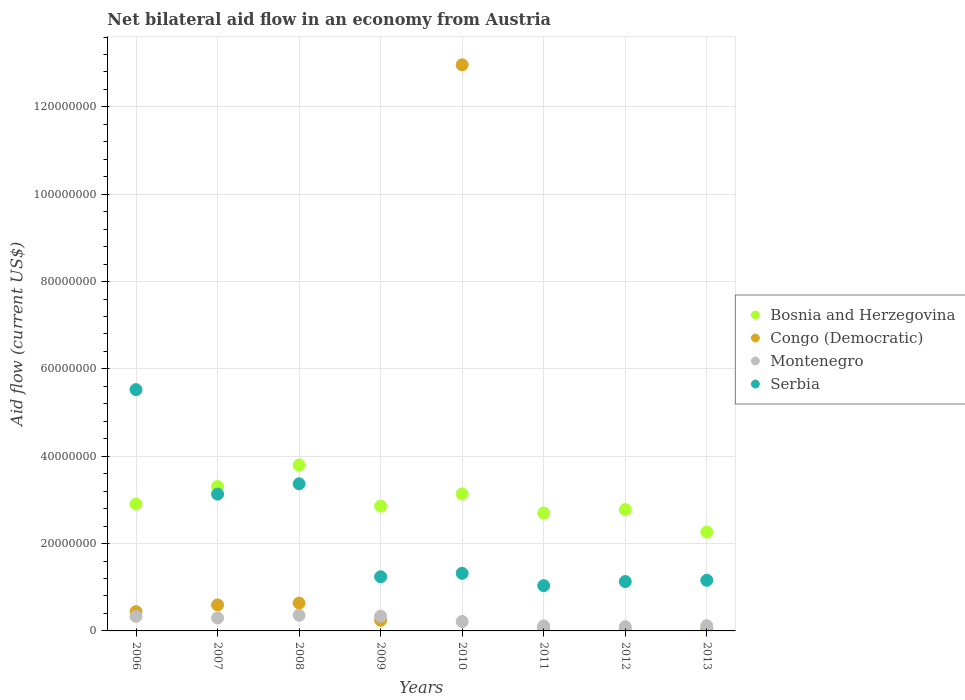How many different coloured dotlines are there?
Your response must be concise. 4. What is the net bilateral aid flow in Bosnia and Herzegovina in 2009?
Your response must be concise. 2.86e+07. Across all years, what is the maximum net bilateral aid flow in Serbia?
Make the answer very short. 5.53e+07. Across all years, what is the minimum net bilateral aid flow in Serbia?
Make the answer very short. 1.04e+07. In which year was the net bilateral aid flow in Montenegro maximum?
Your response must be concise. 2008. What is the total net bilateral aid flow in Congo (Democratic) in the graph?
Keep it short and to the point. 1.50e+08. What is the difference between the net bilateral aid flow in Serbia in 2006 and the net bilateral aid flow in Montenegro in 2009?
Give a very brief answer. 5.19e+07. What is the average net bilateral aid flow in Bosnia and Herzegovina per year?
Your answer should be very brief. 2.97e+07. In the year 2010, what is the difference between the net bilateral aid flow in Congo (Democratic) and net bilateral aid flow in Bosnia and Herzegovina?
Ensure brevity in your answer.  9.83e+07. What is the ratio of the net bilateral aid flow in Montenegro in 2008 to that in 2013?
Offer a very short reply. 3.01. Is the net bilateral aid flow in Serbia in 2006 less than that in 2008?
Offer a terse response. No. What is the difference between the highest and the second highest net bilateral aid flow in Serbia?
Offer a very short reply. 2.16e+07. What is the difference between the highest and the lowest net bilateral aid flow in Bosnia and Herzegovina?
Offer a terse response. 1.54e+07. In how many years, is the net bilateral aid flow in Bosnia and Herzegovina greater than the average net bilateral aid flow in Bosnia and Herzegovina taken over all years?
Your answer should be compact. 3. Is it the case that in every year, the sum of the net bilateral aid flow in Bosnia and Herzegovina and net bilateral aid flow in Serbia  is greater than the sum of net bilateral aid flow in Congo (Democratic) and net bilateral aid flow in Montenegro?
Give a very brief answer. No. Does the net bilateral aid flow in Congo (Democratic) monotonically increase over the years?
Your answer should be very brief. No. How many dotlines are there?
Your answer should be very brief. 4. How many years are there in the graph?
Provide a short and direct response. 8. What is the difference between two consecutive major ticks on the Y-axis?
Your answer should be compact. 2.00e+07. Does the graph contain any zero values?
Your response must be concise. No. How are the legend labels stacked?
Give a very brief answer. Vertical. What is the title of the graph?
Offer a terse response. Net bilateral aid flow in an economy from Austria. Does "Switzerland" appear as one of the legend labels in the graph?
Offer a terse response. No. What is the label or title of the Y-axis?
Your answer should be compact. Aid flow (current US$). What is the Aid flow (current US$) of Bosnia and Herzegovina in 2006?
Provide a succinct answer. 2.91e+07. What is the Aid flow (current US$) of Congo (Democratic) in 2006?
Give a very brief answer. 4.41e+06. What is the Aid flow (current US$) in Montenegro in 2006?
Make the answer very short. 3.34e+06. What is the Aid flow (current US$) of Serbia in 2006?
Your response must be concise. 5.53e+07. What is the Aid flow (current US$) of Bosnia and Herzegovina in 2007?
Your answer should be compact. 3.31e+07. What is the Aid flow (current US$) of Congo (Democratic) in 2007?
Your answer should be very brief. 5.95e+06. What is the Aid flow (current US$) in Montenegro in 2007?
Your response must be concise. 2.97e+06. What is the Aid flow (current US$) of Serbia in 2007?
Give a very brief answer. 3.13e+07. What is the Aid flow (current US$) of Bosnia and Herzegovina in 2008?
Ensure brevity in your answer.  3.80e+07. What is the Aid flow (current US$) in Congo (Democratic) in 2008?
Ensure brevity in your answer.  6.38e+06. What is the Aid flow (current US$) of Montenegro in 2008?
Provide a short and direct response. 3.58e+06. What is the Aid flow (current US$) in Serbia in 2008?
Ensure brevity in your answer.  3.37e+07. What is the Aid flow (current US$) of Bosnia and Herzegovina in 2009?
Offer a terse response. 2.86e+07. What is the Aid flow (current US$) of Congo (Democratic) in 2009?
Make the answer very short. 2.43e+06. What is the Aid flow (current US$) in Montenegro in 2009?
Your response must be concise. 3.37e+06. What is the Aid flow (current US$) in Serbia in 2009?
Your answer should be compact. 1.24e+07. What is the Aid flow (current US$) of Bosnia and Herzegovina in 2010?
Keep it short and to the point. 3.14e+07. What is the Aid flow (current US$) in Congo (Democratic) in 2010?
Provide a short and direct response. 1.30e+08. What is the Aid flow (current US$) in Montenegro in 2010?
Offer a terse response. 2.15e+06. What is the Aid flow (current US$) of Serbia in 2010?
Keep it short and to the point. 1.32e+07. What is the Aid flow (current US$) of Bosnia and Herzegovina in 2011?
Give a very brief answer. 2.70e+07. What is the Aid flow (current US$) of Congo (Democratic) in 2011?
Offer a very short reply. 7.10e+05. What is the Aid flow (current US$) in Montenegro in 2011?
Make the answer very short. 1.16e+06. What is the Aid flow (current US$) in Serbia in 2011?
Ensure brevity in your answer.  1.04e+07. What is the Aid flow (current US$) of Bosnia and Herzegovina in 2012?
Offer a very short reply. 2.78e+07. What is the Aid flow (current US$) of Montenegro in 2012?
Provide a succinct answer. 9.60e+05. What is the Aid flow (current US$) of Serbia in 2012?
Give a very brief answer. 1.13e+07. What is the Aid flow (current US$) in Bosnia and Herzegovina in 2013?
Give a very brief answer. 2.26e+07. What is the Aid flow (current US$) in Montenegro in 2013?
Offer a very short reply. 1.19e+06. What is the Aid flow (current US$) in Serbia in 2013?
Offer a very short reply. 1.16e+07. Across all years, what is the maximum Aid flow (current US$) in Bosnia and Herzegovina?
Your answer should be very brief. 3.80e+07. Across all years, what is the maximum Aid flow (current US$) in Congo (Democratic)?
Your answer should be very brief. 1.30e+08. Across all years, what is the maximum Aid flow (current US$) of Montenegro?
Offer a very short reply. 3.58e+06. Across all years, what is the maximum Aid flow (current US$) of Serbia?
Keep it short and to the point. 5.53e+07. Across all years, what is the minimum Aid flow (current US$) in Bosnia and Herzegovina?
Your answer should be compact. 2.26e+07. Across all years, what is the minimum Aid flow (current US$) of Congo (Democratic)?
Offer a very short reply. 2.40e+05. Across all years, what is the minimum Aid flow (current US$) in Montenegro?
Provide a succinct answer. 9.60e+05. Across all years, what is the minimum Aid flow (current US$) in Serbia?
Provide a succinct answer. 1.04e+07. What is the total Aid flow (current US$) of Bosnia and Herzegovina in the graph?
Make the answer very short. 2.38e+08. What is the total Aid flow (current US$) of Congo (Democratic) in the graph?
Your answer should be compact. 1.50e+08. What is the total Aid flow (current US$) in Montenegro in the graph?
Your answer should be very brief. 1.87e+07. What is the total Aid flow (current US$) of Serbia in the graph?
Provide a short and direct response. 1.79e+08. What is the difference between the Aid flow (current US$) of Bosnia and Herzegovina in 2006 and that in 2007?
Offer a very short reply. -4.01e+06. What is the difference between the Aid flow (current US$) of Congo (Democratic) in 2006 and that in 2007?
Ensure brevity in your answer.  -1.54e+06. What is the difference between the Aid flow (current US$) of Serbia in 2006 and that in 2007?
Offer a terse response. 2.39e+07. What is the difference between the Aid flow (current US$) in Bosnia and Herzegovina in 2006 and that in 2008?
Offer a very short reply. -8.93e+06. What is the difference between the Aid flow (current US$) in Congo (Democratic) in 2006 and that in 2008?
Provide a succinct answer. -1.97e+06. What is the difference between the Aid flow (current US$) of Serbia in 2006 and that in 2008?
Offer a terse response. 2.16e+07. What is the difference between the Aid flow (current US$) of Bosnia and Herzegovina in 2006 and that in 2009?
Your answer should be very brief. 4.80e+05. What is the difference between the Aid flow (current US$) of Congo (Democratic) in 2006 and that in 2009?
Provide a succinct answer. 1.98e+06. What is the difference between the Aid flow (current US$) in Montenegro in 2006 and that in 2009?
Ensure brevity in your answer.  -3.00e+04. What is the difference between the Aid flow (current US$) in Serbia in 2006 and that in 2009?
Offer a very short reply. 4.29e+07. What is the difference between the Aid flow (current US$) in Bosnia and Herzegovina in 2006 and that in 2010?
Keep it short and to the point. -2.31e+06. What is the difference between the Aid flow (current US$) of Congo (Democratic) in 2006 and that in 2010?
Make the answer very short. -1.25e+08. What is the difference between the Aid flow (current US$) of Montenegro in 2006 and that in 2010?
Ensure brevity in your answer.  1.19e+06. What is the difference between the Aid flow (current US$) of Serbia in 2006 and that in 2010?
Offer a very short reply. 4.21e+07. What is the difference between the Aid flow (current US$) in Bosnia and Herzegovina in 2006 and that in 2011?
Provide a short and direct response. 2.06e+06. What is the difference between the Aid flow (current US$) of Congo (Democratic) in 2006 and that in 2011?
Offer a terse response. 3.70e+06. What is the difference between the Aid flow (current US$) of Montenegro in 2006 and that in 2011?
Make the answer very short. 2.18e+06. What is the difference between the Aid flow (current US$) in Serbia in 2006 and that in 2011?
Give a very brief answer. 4.49e+07. What is the difference between the Aid flow (current US$) of Bosnia and Herzegovina in 2006 and that in 2012?
Offer a terse response. 1.29e+06. What is the difference between the Aid flow (current US$) in Congo (Democratic) in 2006 and that in 2012?
Offer a terse response. 4.17e+06. What is the difference between the Aid flow (current US$) in Montenegro in 2006 and that in 2012?
Your answer should be compact. 2.38e+06. What is the difference between the Aid flow (current US$) of Serbia in 2006 and that in 2012?
Offer a terse response. 4.40e+07. What is the difference between the Aid flow (current US$) in Bosnia and Herzegovina in 2006 and that in 2013?
Your answer should be very brief. 6.42e+06. What is the difference between the Aid flow (current US$) in Congo (Democratic) in 2006 and that in 2013?
Your answer should be very brief. 4.02e+06. What is the difference between the Aid flow (current US$) in Montenegro in 2006 and that in 2013?
Your answer should be compact. 2.15e+06. What is the difference between the Aid flow (current US$) in Serbia in 2006 and that in 2013?
Offer a very short reply. 4.37e+07. What is the difference between the Aid flow (current US$) of Bosnia and Herzegovina in 2007 and that in 2008?
Offer a very short reply. -4.92e+06. What is the difference between the Aid flow (current US$) in Congo (Democratic) in 2007 and that in 2008?
Your response must be concise. -4.30e+05. What is the difference between the Aid flow (current US$) of Montenegro in 2007 and that in 2008?
Your answer should be very brief. -6.10e+05. What is the difference between the Aid flow (current US$) in Serbia in 2007 and that in 2008?
Your answer should be very brief. -2.36e+06. What is the difference between the Aid flow (current US$) in Bosnia and Herzegovina in 2007 and that in 2009?
Your response must be concise. 4.49e+06. What is the difference between the Aid flow (current US$) of Congo (Democratic) in 2007 and that in 2009?
Provide a succinct answer. 3.52e+06. What is the difference between the Aid flow (current US$) of Montenegro in 2007 and that in 2009?
Keep it short and to the point. -4.00e+05. What is the difference between the Aid flow (current US$) in Serbia in 2007 and that in 2009?
Your answer should be compact. 1.89e+07. What is the difference between the Aid flow (current US$) in Bosnia and Herzegovina in 2007 and that in 2010?
Your answer should be very brief. 1.70e+06. What is the difference between the Aid flow (current US$) of Congo (Democratic) in 2007 and that in 2010?
Make the answer very short. -1.24e+08. What is the difference between the Aid flow (current US$) in Montenegro in 2007 and that in 2010?
Provide a short and direct response. 8.20e+05. What is the difference between the Aid flow (current US$) of Serbia in 2007 and that in 2010?
Offer a very short reply. 1.81e+07. What is the difference between the Aid flow (current US$) of Bosnia and Herzegovina in 2007 and that in 2011?
Ensure brevity in your answer.  6.07e+06. What is the difference between the Aid flow (current US$) of Congo (Democratic) in 2007 and that in 2011?
Your answer should be very brief. 5.24e+06. What is the difference between the Aid flow (current US$) of Montenegro in 2007 and that in 2011?
Provide a succinct answer. 1.81e+06. What is the difference between the Aid flow (current US$) of Serbia in 2007 and that in 2011?
Your response must be concise. 2.10e+07. What is the difference between the Aid flow (current US$) of Bosnia and Herzegovina in 2007 and that in 2012?
Offer a terse response. 5.30e+06. What is the difference between the Aid flow (current US$) in Congo (Democratic) in 2007 and that in 2012?
Give a very brief answer. 5.71e+06. What is the difference between the Aid flow (current US$) of Montenegro in 2007 and that in 2012?
Offer a terse response. 2.01e+06. What is the difference between the Aid flow (current US$) of Serbia in 2007 and that in 2012?
Your answer should be compact. 2.00e+07. What is the difference between the Aid flow (current US$) of Bosnia and Herzegovina in 2007 and that in 2013?
Give a very brief answer. 1.04e+07. What is the difference between the Aid flow (current US$) in Congo (Democratic) in 2007 and that in 2013?
Keep it short and to the point. 5.56e+06. What is the difference between the Aid flow (current US$) in Montenegro in 2007 and that in 2013?
Provide a short and direct response. 1.78e+06. What is the difference between the Aid flow (current US$) in Serbia in 2007 and that in 2013?
Your answer should be very brief. 1.97e+07. What is the difference between the Aid flow (current US$) in Bosnia and Herzegovina in 2008 and that in 2009?
Ensure brevity in your answer.  9.41e+06. What is the difference between the Aid flow (current US$) of Congo (Democratic) in 2008 and that in 2009?
Make the answer very short. 3.95e+06. What is the difference between the Aid flow (current US$) of Montenegro in 2008 and that in 2009?
Provide a short and direct response. 2.10e+05. What is the difference between the Aid flow (current US$) of Serbia in 2008 and that in 2009?
Provide a succinct answer. 2.13e+07. What is the difference between the Aid flow (current US$) in Bosnia and Herzegovina in 2008 and that in 2010?
Keep it short and to the point. 6.62e+06. What is the difference between the Aid flow (current US$) of Congo (Democratic) in 2008 and that in 2010?
Your response must be concise. -1.23e+08. What is the difference between the Aid flow (current US$) of Montenegro in 2008 and that in 2010?
Your answer should be compact. 1.43e+06. What is the difference between the Aid flow (current US$) of Serbia in 2008 and that in 2010?
Ensure brevity in your answer.  2.05e+07. What is the difference between the Aid flow (current US$) in Bosnia and Herzegovina in 2008 and that in 2011?
Your answer should be compact. 1.10e+07. What is the difference between the Aid flow (current US$) in Congo (Democratic) in 2008 and that in 2011?
Keep it short and to the point. 5.67e+06. What is the difference between the Aid flow (current US$) in Montenegro in 2008 and that in 2011?
Offer a very short reply. 2.42e+06. What is the difference between the Aid flow (current US$) in Serbia in 2008 and that in 2011?
Offer a terse response. 2.33e+07. What is the difference between the Aid flow (current US$) in Bosnia and Herzegovina in 2008 and that in 2012?
Provide a short and direct response. 1.02e+07. What is the difference between the Aid flow (current US$) of Congo (Democratic) in 2008 and that in 2012?
Keep it short and to the point. 6.14e+06. What is the difference between the Aid flow (current US$) in Montenegro in 2008 and that in 2012?
Give a very brief answer. 2.62e+06. What is the difference between the Aid flow (current US$) of Serbia in 2008 and that in 2012?
Your answer should be very brief. 2.24e+07. What is the difference between the Aid flow (current US$) of Bosnia and Herzegovina in 2008 and that in 2013?
Provide a succinct answer. 1.54e+07. What is the difference between the Aid flow (current US$) of Congo (Democratic) in 2008 and that in 2013?
Provide a succinct answer. 5.99e+06. What is the difference between the Aid flow (current US$) in Montenegro in 2008 and that in 2013?
Your answer should be very brief. 2.39e+06. What is the difference between the Aid flow (current US$) in Serbia in 2008 and that in 2013?
Provide a succinct answer. 2.21e+07. What is the difference between the Aid flow (current US$) in Bosnia and Herzegovina in 2009 and that in 2010?
Offer a terse response. -2.79e+06. What is the difference between the Aid flow (current US$) in Congo (Democratic) in 2009 and that in 2010?
Provide a succinct answer. -1.27e+08. What is the difference between the Aid flow (current US$) of Montenegro in 2009 and that in 2010?
Give a very brief answer. 1.22e+06. What is the difference between the Aid flow (current US$) of Serbia in 2009 and that in 2010?
Your answer should be very brief. -7.90e+05. What is the difference between the Aid flow (current US$) in Bosnia and Herzegovina in 2009 and that in 2011?
Provide a short and direct response. 1.58e+06. What is the difference between the Aid flow (current US$) of Congo (Democratic) in 2009 and that in 2011?
Keep it short and to the point. 1.72e+06. What is the difference between the Aid flow (current US$) in Montenegro in 2009 and that in 2011?
Your response must be concise. 2.21e+06. What is the difference between the Aid flow (current US$) in Serbia in 2009 and that in 2011?
Offer a very short reply. 2.03e+06. What is the difference between the Aid flow (current US$) in Bosnia and Herzegovina in 2009 and that in 2012?
Give a very brief answer. 8.10e+05. What is the difference between the Aid flow (current US$) of Congo (Democratic) in 2009 and that in 2012?
Provide a short and direct response. 2.19e+06. What is the difference between the Aid flow (current US$) in Montenegro in 2009 and that in 2012?
Your response must be concise. 2.41e+06. What is the difference between the Aid flow (current US$) of Serbia in 2009 and that in 2012?
Provide a succinct answer. 1.09e+06. What is the difference between the Aid flow (current US$) in Bosnia and Herzegovina in 2009 and that in 2013?
Provide a succinct answer. 5.94e+06. What is the difference between the Aid flow (current US$) of Congo (Democratic) in 2009 and that in 2013?
Your answer should be compact. 2.04e+06. What is the difference between the Aid flow (current US$) of Montenegro in 2009 and that in 2013?
Your answer should be compact. 2.18e+06. What is the difference between the Aid flow (current US$) in Serbia in 2009 and that in 2013?
Make the answer very short. 8.10e+05. What is the difference between the Aid flow (current US$) in Bosnia and Herzegovina in 2010 and that in 2011?
Make the answer very short. 4.37e+06. What is the difference between the Aid flow (current US$) in Congo (Democratic) in 2010 and that in 2011?
Your response must be concise. 1.29e+08. What is the difference between the Aid flow (current US$) in Montenegro in 2010 and that in 2011?
Provide a succinct answer. 9.90e+05. What is the difference between the Aid flow (current US$) in Serbia in 2010 and that in 2011?
Your answer should be very brief. 2.82e+06. What is the difference between the Aid flow (current US$) of Bosnia and Herzegovina in 2010 and that in 2012?
Ensure brevity in your answer.  3.60e+06. What is the difference between the Aid flow (current US$) in Congo (Democratic) in 2010 and that in 2012?
Provide a short and direct response. 1.29e+08. What is the difference between the Aid flow (current US$) in Montenegro in 2010 and that in 2012?
Offer a terse response. 1.19e+06. What is the difference between the Aid flow (current US$) in Serbia in 2010 and that in 2012?
Your answer should be compact. 1.88e+06. What is the difference between the Aid flow (current US$) in Bosnia and Herzegovina in 2010 and that in 2013?
Your answer should be very brief. 8.73e+06. What is the difference between the Aid flow (current US$) of Congo (Democratic) in 2010 and that in 2013?
Offer a very short reply. 1.29e+08. What is the difference between the Aid flow (current US$) of Montenegro in 2010 and that in 2013?
Your response must be concise. 9.60e+05. What is the difference between the Aid flow (current US$) in Serbia in 2010 and that in 2013?
Your answer should be very brief. 1.60e+06. What is the difference between the Aid flow (current US$) of Bosnia and Herzegovina in 2011 and that in 2012?
Provide a short and direct response. -7.70e+05. What is the difference between the Aid flow (current US$) in Congo (Democratic) in 2011 and that in 2012?
Offer a very short reply. 4.70e+05. What is the difference between the Aid flow (current US$) of Serbia in 2011 and that in 2012?
Provide a short and direct response. -9.40e+05. What is the difference between the Aid flow (current US$) in Bosnia and Herzegovina in 2011 and that in 2013?
Keep it short and to the point. 4.36e+06. What is the difference between the Aid flow (current US$) in Montenegro in 2011 and that in 2013?
Offer a terse response. -3.00e+04. What is the difference between the Aid flow (current US$) in Serbia in 2011 and that in 2013?
Offer a terse response. -1.22e+06. What is the difference between the Aid flow (current US$) in Bosnia and Herzegovina in 2012 and that in 2013?
Offer a very short reply. 5.13e+06. What is the difference between the Aid flow (current US$) of Congo (Democratic) in 2012 and that in 2013?
Your response must be concise. -1.50e+05. What is the difference between the Aid flow (current US$) in Serbia in 2012 and that in 2013?
Ensure brevity in your answer.  -2.80e+05. What is the difference between the Aid flow (current US$) of Bosnia and Herzegovina in 2006 and the Aid flow (current US$) of Congo (Democratic) in 2007?
Your answer should be compact. 2.31e+07. What is the difference between the Aid flow (current US$) in Bosnia and Herzegovina in 2006 and the Aid flow (current US$) in Montenegro in 2007?
Offer a very short reply. 2.61e+07. What is the difference between the Aid flow (current US$) in Bosnia and Herzegovina in 2006 and the Aid flow (current US$) in Serbia in 2007?
Give a very brief answer. -2.26e+06. What is the difference between the Aid flow (current US$) in Congo (Democratic) in 2006 and the Aid flow (current US$) in Montenegro in 2007?
Make the answer very short. 1.44e+06. What is the difference between the Aid flow (current US$) of Congo (Democratic) in 2006 and the Aid flow (current US$) of Serbia in 2007?
Give a very brief answer. -2.69e+07. What is the difference between the Aid flow (current US$) of Montenegro in 2006 and the Aid flow (current US$) of Serbia in 2007?
Keep it short and to the point. -2.80e+07. What is the difference between the Aid flow (current US$) in Bosnia and Herzegovina in 2006 and the Aid flow (current US$) in Congo (Democratic) in 2008?
Provide a short and direct response. 2.27e+07. What is the difference between the Aid flow (current US$) of Bosnia and Herzegovina in 2006 and the Aid flow (current US$) of Montenegro in 2008?
Ensure brevity in your answer.  2.55e+07. What is the difference between the Aid flow (current US$) of Bosnia and Herzegovina in 2006 and the Aid flow (current US$) of Serbia in 2008?
Keep it short and to the point. -4.62e+06. What is the difference between the Aid flow (current US$) in Congo (Democratic) in 2006 and the Aid flow (current US$) in Montenegro in 2008?
Give a very brief answer. 8.30e+05. What is the difference between the Aid flow (current US$) in Congo (Democratic) in 2006 and the Aid flow (current US$) in Serbia in 2008?
Ensure brevity in your answer.  -2.93e+07. What is the difference between the Aid flow (current US$) of Montenegro in 2006 and the Aid flow (current US$) of Serbia in 2008?
Your response must be concise. -3.04e+07. What is the difference between the Aid flow (current US$) in Bosnia and Herzegovina in 2006 and the Aid flow (current US$) in Congo (Democratic) in 2009?
Provide a succinct answer. 2.66e+07. What is the difference between the Aid flow (current US$) in Bosnia and Herzegovina in 2006 and the Aid flow (current US$) in Montenegro in 2009?
Your answer should be compact. 2.57e+07. What is the difference between the Aid flow (current US$) of Bosnia and Herzegovina in 2006 and the Aid flow (current US$) of Serbia in 2009?
Your response must be concise. 1.67e+07. What is the difference between the Aid flow (current US$) of Congo (Democratic) in 2006 and the Aid flow (current US$) of Montenegro in 2009?
Offer a very short reply. 1.04e+06. What is the difference between the Aid flow (current US$) of Congo (Democratic) in 2006 and the Aid flow (current US$) of Serbia in 2009?
Keep it short and to the point. -7.99e+06. What is the difference between the Aid flow (current US$) in Montenegro in 2006 and the Aid flow (current US$) in Serbia in 2009?
Provide a succinct answer. -9.06e+06. What is the difference between the Aid flow (current US$) of Bosnia and Herzegovina in 2006 and the Aid flow (current US$) of Congo (Democratic) in 2010?
Offer a very short reply. -1.01e+08. What is the difference between the Aid flow (current US$) of Bosnia and Herzegovina in 2006 and the Aid flow (current US$) of Montenegro in 2010?
Your answer should be very brief. 2.69e+07. What is the difference between the Aid flow (current US$) of Bosnia and Herzegovina in 2006 and the Aid flow (current US$) of Serbia in 2010?
Provide a succinct answer. 1.59e+07. What is the difference between the Aid flow (current US$) in Congo (Democratic) in 2006 and the Aid flow (current US$) in Montenegro in 2010?
Your answer should be compact. 2.26e+06. What is the difference between the Aid flow (current US$) of Congo (Democratic) in 2006 and the Aid flow (current US$) of Serbia in 2010?
Make the answer very short. -8.78e+06. What is the difference between the Aid flow (current US$) in Montenegro in 2006 and the Aid flow (current US$) in Serbia in 2010?
Your response must be concise. -9.85e+06. What is the difference between the Aid flow (current US$) in Bosnia and Herzegovina in 2006 and the Aid flow (current US$) in Congo (Democratic) in 2011?
Make the answer very short. 2.84e+07. What is the difference between the Aid flow (current US$) of Bosnia and Herzegovina in 2006 and the Aid flow (current US$) of Montenegro in 2011?
Offer a very short reply. 2.79e+07. What is the difference between the Aid flow (current US$) of Bosnia and Herzegovina in 2006 and the Aid flow (current US$) of Serbia in 2011?
Keep it short and to the point. 1.87e+07. What is the difference between the Aid flow (current US$) of Congo (Democratic) in 2006 and the Aid flow (current US$) of Montenegro in 2011?
Your response must be concise. 3.25e+06. What is the difference between the Aid flow (current US$) of Congo (Democratic) in 2006 and the Aid flow (current US$) of Serbia in 2011?
Offer a very short reply. -5.96e+06. What is the difference between the Aid flow (current US$) in Montenegro in 2006 and the Aid flow (current US$) in Serbia in 2011?
Keep it short and to the point. -7.03e+06. What is the difference between the Aid flow (current US$) of Bosnia and Herzegovina in 2006 and the Aid flow (current US$) of Congo (Democratic) in 2012?
Provide a short and direct response. 2.88e+07. What is the difference between the Aid flow (current US$) of Bosnia and Herzegovina in 2006 and the Aid flow (current US$) of Montenegro in 2012?
Offer a very short reply. 2.81e+07. What is the difference between the Aid flow (current US$) of Bosnia and Herzegovina in 2006 and the Aid flow (current US$) of Serbia in 2012?
Your answer should be very brief. 1.78e+07. What is the difference between the Aid flow (current US$) in Congo (Democratic) in 2006 and the Aid flow (current US$) in Montenegro in 2012?
Make the answer very short. 3.45e+06. What is the difference between the Aid flow (current US$) in Congo (Democratic) in 2006 and the Aid flow (current US$) in Serbia in 2012?
Give a very brief answer. -6.90e+06. What is the difference between the Aid flow (current US$) of Montenegro in 2006 and the Aid flow (current US$) of Serbia in 2012?
Provide a succinct answer. -7.97e+06. What is the difference between the Aid flow (current US$) of Bosnia and Herzegovina in 2006 and the Aid flow (current US$) of Congo (Democratic) in 2013?
Keep it short and to the point. 2.87e+07. What is the difference between the Aid flow (current US$) of Bosnia and Herzegovina in 2006 and the Aid flow (current US$) of Montenegro in 2013?
Provide a short and direct response. 2.79e+07. What is the difference between the Aid flow (current US$) of Bosnia and Herzegovina in 2006 and the Aid flow (current US$) of Serbia in 2013?
Provide a short and direct response. 1.75e+07. What is the difference between the Aid flow (current US$) of Congo (Democratic) in 2006 and the Aid flow (current US$) of Montenegro in 2013?
Your response must be concise. 3.22e+06. What is the difference between the Aid flow (current US$) in Congo (Democratic) in 2006 and the Aid flow (current US$) in Serbia in 2013?
Offer a terse response. -7.18e+06. What is the difference between the Aid flow (current US$) of Montenegro in 2006 and the Aid flow (current US$) of Serbia in 2013?
Provide a short and direct response. -8.25e+06. What is the difference between the Aid flow (current US$) in Bosnia and Herzegovina in 2007 and the Aid flow (current US$) in Congo (Democratic) in 2008?
Ensure brevity in your answer.  2.67e+07. What is the difference between the Aid flow (current US$) in Bosnia and Herzegovina in 2007 and the Aid flow (current US$) in Montenegro in 2008?
Offer a very short reply. 2.95e+07. What is the difference between the Aid flow (current US$) in Bosnia and Herzegovina in 2007 and the Aid flow (current US$) in Serbia in 2008?
Offer a terse response. -6.10e+05. What is the difference between the Aid flow (current US$) in Congo (Democratic) in 2007 and the Aid flow (current US$) in Montenegro in 2008?
Provide a succinct answer. 2.37e+06. What is the difference between the Aid flow (current US$) of Congo (Democratic) in 2007 and the Aid flow (current US$) of Serbia in 2008?
Your answer should be compact. -2.77e+07. What is the difference between the Aid flow (current US$) in Montenegro in 2007 and the Aid flow (current US$) in Serbia in 2008?
Make the answer very short. -3.07e+07. What is the difference between the Aid flow (current US$) of Bosnia and Herzegovina in 2007 and the Aid flow (current US$) of Congo (Democratic) in 2009?
Ensure brevity in your answer.  3.06e+07. What is the difference between the Aid flow (current US$) of Bosnia and Herzegovina in 2007 and the Aid flow (current US$) of Montenegro in 2009?
Your answer should be compact. 2.97e+07. What is the difference between the Aid flow (current US$) in Bosnia and Herzegovina in 2007 and the Aid flow (current US$) in Serbia in 2009?
Your response must be concise. 2.07e+07. What is the difference between the Aid flow (current US$) of Congo (Democratic) in 2007 and the Aid flow (current US$) of Montenegro in 2009?
Keep it short and to the point. 2.58e+06. What is the difference between the Aid flow (current US$) in Congo (Democratic) in 2007 and the Aid flow (current US$) in Serbia in 2009?
Offer a terse response. -6.45e+06. What is the difference between the Aid flow (current US$) in Montenegro in 2007 and the Aid flow (current US$) in Serbia in 2009?
Offer a terse response. -9.43e+06. What is the difference between the Aid flow (current US$) in Bosnia and Herzegovina in 2007 and the Aid flow (current US$) in Congo (Democratic) in 2010?
Your response must be concise. -9.66e+07. What is the difference between the Aid flow (current US$) in Bosnia and Herzegovina in 2007 and the Aid flow (current US$) in Montenegro in 2010?
Provide a short and direct response. 3.09e+07. What is the difference between the Aid flow (current US$) in Bosnia and Herzegovina in 2007 and the Aid flow (current US$) in Serbia in 2010?
Offer a terse response. 1.99e+07. What is the difference between the Aid flow (current US$) in Congo (Democratic) in 2007 and the Aid flow (current US$) in Montenegro in 2010?
Offer a very short reply. 3.80e+06. What is the difference between the Aid flow (current US$) in Congo (Democratic) in 2007 and the Aid flow (current US$) in Serbia in 2010?
Ensure brevity in your answer.  -7.24e+06. What is the difference between the Aid flow (current US$) in Montenegro in 2007 and the Aid flow (current US$) in Serbia in 2010?
Your answer should be very brief. -1.02e+07. What is the difference between the Aid flow (current US$) in Bosnia and Herzegovina in 2007 and the Aid flow (current US$) in Congo (Democratic) in 2011?
Provide a succinct answer. 3.24e+07. What is the difference between the Aid flow (current US$) in Bosnia and Herzegovina in 2007 and the Aid flow (current US$) in Montenegro in 2011?
Ensure brevity in your answer.  3.19e+07. What is the difference between the Aid flow (current US$) of Bosnia and Herzegovina in 2007 and the Aid flow (current US$) of Serbia in 2011?
Ensure brevity in your answer.  2.27e+07. What is the difference between the Aid flow (current US$) of Congo (Democratic) in 2007 and the Aid flow (current US$) of Montenegro in 2011?
Give a very brief answer. 4.79e+06. What is the difference between the Aid flow (current US$) in Congo (Democratic) in 2007 and the Aid flow (current US$) in Serbia in 2011?
Offer a terse response. -4.42e+06. What is the difference between the Aid flow (current US$) in Montenegro in 2007 and the Aid flow (current US$) in Serbia in 2011?
Provide a short and direct response. -7.40e+06. What is the difference between the Aid flow (current US$) of Bosnia and Herzegovina in 2007 and the Aid flow (current US$) of Congo (Democratic) in 2012?
Give a very brief answer. 3.28e+07. What is the difference between the Aid flow (current US$) of Bosnia and Herzegovina in 2007 and the Aid flow (current US$) of Montenegro in 2012?
Offer a very short reply. 3.21e+07. What is the difference between the Aid flow (current US$) in Bosnia and Herzegovina in 2007 and the Aid flow (current US$) in Serbia in 2012?
Ensure brevity in your answer.  2.18e+07. What is the difference between the Aid flow (current US$) in Congo (Democratic) in 2007 and the Aid flow (current US$) in Montenegro in 2012?
Provide a succinct answer. 4.99e+06. What is the difference between the Aid flow (current US$) in Congo (Democratic) in 2007 and the Aid flow (current US$) in Serbia in 2012?
Your answer should be very brief. -5.36e+06. What is the difference between the Aid flow (current US$) of Montenegro in 2007 and the Aid flow (current US$) of Serbia in 2012?
Keep it short and to the point. -8.34e+06. What is the difference between the Aid flow (current US$) of Bosnia and Herzegovina in 2007 and the Aid flow (current US$) of Congo (Democratic) in 2013?
Offer a terse response. 3.27e+07. What is the difference between the Aid flow (current US$) in Bosnia and Herzegovina in 2007 and the Aid flow (current US$) in Montenegro in 2013?
Provide a short and direct response. 3.19e+07. What is the difference between the Aid flow (current US$) in Bosnia and Herzegovina in 2007 and the Aid flow (current US$) in Serbia in 2013?
Provide a short and direct response. 2.15e+07. What is the difference between the Aid flow (current US$) of Congo (Democratic) in 2007 and the Aid flow (current US$) of Montenegro in 2013?
Your response must be concise. 4.76e+06. What is the difference between the Aid flow (current US$) of Congo (Democratic) in 2007 and the Aid flow (current US$) of Serbia in 2013?
Offer a very short reply. -5.64e+06. What is the difference between the Aid flow (current US$) of Montenegro in 2007 and the Aid flow (current US$) of Serbia in 2013?
Make the answer very short. -8.62e+06. What is the difference between the Aid flow (current US$) of Bosnia and Herzegovina in 2008 and the Aid flow (current US$) of Congo (Democratic) in 2009?
Offer a terse response. 3.56e+07. What is the difference between the Aid flow (current US$) of Bosnia and Herzegovina in 2008 and the Aid flow (current US$) of Montenegro in 2009?
Offer a terse response. 3.46e+07. What is the difference between the Aid flow (current US$) in Bosnia and Herzegovina in 2008 and the Aid flow (current US$) in Serbia in 2009?
Your response must be concise. 2.56e+07. What is the difference between the Aid flow (current US$) of Congo (Democratic) in 2008 and the Aid flow (current US$) of Montenegro in 2009?
Offer a very short reply. 3.01e+06. What is the difference between the Aid flow (current US$) of Congo (Democratic) in 2008 and the Aid flow (current US$) of Serbia in 2009?
Offer a terse response. -6.02e+06. What is the difference between the Aid flow (current US$) of Montenegro in 2008 and the Aid flow (current US$) of Serbia in 2009?
Provide a short and direct response. -8.82e+06. What is the difference between the Aid flow (current US$) of Bosnia and Herzegovina in 2008 and the Aid flow (current US$) of Congo (Democratic) in 2010?
Make the answer very short. -9.16e+07. What is the difference between the Aid flow (current US$) of Bosnia and Herzegovina in 2008 and the Aid flow (current US$) of Montenegro in 2010?
Offer a terse response. 3.58e+07. What is the difference between the Aid flow (current US$) of Bosnia and Herzegovina in 2008 and the Aid flow (current US$) of Serbia in 2010?
Provide a succinct answer. 2.48e+07. What is the difference between the Aid flow (current US$) in Congo (Democratic) in 2008 and the Aid flow (current US$) in Montenegro in 2010?
Your answer should be compact. 4.23e+06. What is the difference between the Aid flow (current US$) of Congo (Democratic) in 2008 and the Aid flow (current US$) of Serbia in 2010?
Make the answer very short. -6.81e+06. What is the difference between the Aid flow (current US$) of Montenegro in 2008 and the Aid flow (current US$) of Serbia in 2010?
Provide a succinct answer. -9.61e+06. What is the difference between the Aid flow (current US$) of Bosnia and Herzegovina in 2008 and the Aid flow (current US$) of Congo (Democratic) in 2011?
Keep it short and to the point. 3.73e+07. What is the difference between the Aid flow (current US$) in Bosnia and Herzegovina in 2008 and the Aid flow (current US$) in Montenegro in 2011?
Your response must be concise. 3.68e+07. What is the difference between the Aid flow (current US$) of Bosnia and Herzegovina in 2008 and the Aid flow (current US$) of Serbia in 2011?
Make the answer very short. 2.76e+07. What is the difference between the Aid flow (current US$) in Congo (Democratic) in 2008 and the Aid flow (current US$) in Montenegro in 2011?
Offer a very short reply. 5.22e+06. What is the difference between the Aid flow (current US$) of Congo (Democratic) in 2008 and the Aid flow (current US$) of Serbia in 2011?
Provide a short and direct response. -3.99e+06. What is the difference between the Aid flow (current US$) in Montenegro in 2008 and the Aid flow (current US$) in Serbia in 2011?
Ensure brevity in your answer.  -6.79e+06. What is the difference between the Aid flow (current US$) in Bosnia and Herzegovina in 2008 and the Aid flow (current US$) in Congo (Democratic) in 2012?
Give a very brief answer. 3.78e+07. What is the difference between the Aid flow (current US$) in Bosnia and Herzegovina in 2008 and the Aid flow (current US$) in Montenegro in 2012?
Offer a very short reply. 3.70e+07. What is the difference between the Aid flow (current US$) of Bosnia and Herzegovina in 2008 and the Aid flow (current US$) of Serbia in 2012?
Provide a succinct answer. 2.67e+07. What is the difference between the Aid flow (current US$) of Congo (Democratic) in 2008 and the Aid flow (current US$) of Montenegro in 2012?
Your answer should be very brief. 5.42e+06. What is the difference between the Aid flow (current US$) of Congo (Democratic) in 2008 and the Aid flow (current US$) of Serbia in 2012?
Give a very brief answer. -4.93e+06. What is the difference between the Aid flow (current US$) of Montenegro in 2008 and the Aid flow (current US$) of Serbia in 2012?
Make the answer very short. -7.73e+06. What is the difference between the Aid flow (current US$) in Bosnia and Herzegovina in 2008 and the Aid flow (current US$) in Congo (Democratic) in 2013?
Make the answer very short. 3.76e+07. What is the difference between the Aid flow (current US$) in Bosnia and Herzegovina in 2008 and the Aid flow (current US$) in Montenegro in 2013?
Give a very brief answer. 3.68e+07. What is the difference between the Aid flow (current US$) in Bosnia and Herzegovina in 2008 and the Aid flow (current US$) in Serbia in 2013?
Offer a very short reply. 2.64e+07. What is the difference between the Aid flow (current US$) in Congo (Democratic) in 2008 and the Aid flow (current US$) in Montenegro in 2013?
Keep it short and to the point. 5.19e+06. What is the difference between the Aid flow (current US$) of Congo (Democratic) in 2008 and the Aid flow (current US$) of Serbia in 2013?
Keep it short and to the point. -5.21e+06. What is the difference between the Aid flow (current US$) in Montenegro in 2008 and the Aid flow (current US$) in Serbia in 2013?
Your response must be concise. -8.01e+06. What is the difference between the Aid flow (current US$) in Bosnia and Herzegovina in 2009 and the Aid flow (current US$) in Congo (Democratic) in 2010?
Make the answer very short. -1.01e+08. What is the difference between the Aid flow (current US$) of Bosnia and Herzegovina in 2009 and the Aid flow (current US$) of Montenegro in 2010?
Provide a short and direct response. 2.64e+07. What is the difference between the Aid flow (current US$) of Bosnia and Herzegovina in 2009 and the Aid flow (current US$) of Serbia in 2010?
Give a very brief answer. 1.54e+07. What is the difference between the Aid flow (current US$) in Congo (Democratic) in 2009 and the Aid flow (current US$) in Montenegro in 2010?
Provide a short and direct response. 2.80e+05. What is the difference between the Aid flow (current US$) of Congo (Democratic) in 2009 and the Aid flow (current US$) of Serbia in 2010?
Make the answer very short. -1.08e+07. What is the difference between the Aid flow (current US$) in Montenegro in 2009 and the Aid flow (current US$) in Serbia in 2010?
Keep it short and to the point. -9.82e+06. What is the difference between the Aid flow (current US$) of Bosnia and Herzegovina in 2009 and the Aid flow (current US$) of Congo (Democratic) in 2011?
Your answer should be compact. 2.79e+07. What is the difference between the Aid flow (current US$) in Bosnia and Herzegovina in 2009 and the Aid flow (current US$) in Montenegro in 2011?
Give a very brief answer. 2.74e+07. What is the difference between the Aid flow (current US$) of Bosnia and Herzegovina in 2009 and the Aid flow (current US$) of Serbia in 2011?
Offer a very short reply. 1.82e+07. What is the difference between the Aid flow (current US$) in Congo (Democratic) in 2009 and the Aid flow (current US$) in Montenegro in 2011?
Give a very brief answer. 1.27e+06. What is the difference between the Aid flow (current US$) of Congo (Democratic) in 2009 and the Aid flow (current US$) of Serbia in 2011?
Provide a succinct answer. -7.94e+06. What is the difference between the Aid flow (current US$) of Montenegro in 2009 and the Aid flow (current US$) of Serbia in 2011?
Provide a short and direct response. -7.00e+06. What is the difference between the Aid flow (current US$) of Bosnia and Herzegovina in 2009 and the Aid flow (current US$) of Congo (Democratic) in 2012?
Offer a terse response. 2.84e+07. What is the difference between the Aid flow (current US$) of Bosnia and Herzegovina in 2009 and the Aid flow (current US$) of Montenegro in 2012?
Keep it short and to the point. 2.76e+07. What is the difference between the Aid flow (current US$) of Bosnia and Herzegovina in 2009 and the Aid flow (current US$) of Serbia in 2012?
Ensure brevity in your answer.  1.73e+07. What is the difference between the Aid flow (current US$) in Congo (Democratic) in 2009 and the Aid flow (current US$) in Montenegro in 2012?
Keep it short and to the point. 1.47e+06. What is the difference between the Aid flow (current US$) of Congo (Democratic) in 2009 and the Aid flow (current US$) of Serbia in 2012?
Your answer should be compact. -8.88e+06. What is the difference between the Aid flow (current US$) in Montenegro in 2009 and the Aid flow (current US$) in Serbia in 2012?
Keep it short and to the point. -7.94e+06. What is the difference between the Aid flow (current US$) in Bosnia and Herzegovina in 2009 and the Aid flow (current US$) in Congo (Democratic) in 2013?
Give a very brief answer. 2.82e+07. What is the difference between the Aid flow (current US$) in Bosnia and Herzegovina in 2009 and the Aid flow (current US$) in Montenegro in 2013?
Offer a very short reply. 2.74e+07. What is the difference between the Aid flow (current US$) in Bosnia and Herzegovina in 2009 and the Aid flow (current US$) in Serbia in 2013?
Provide a succinct answer. 1.70e+07. What is the difference between the Aid flow (current US$) of Congo (Democratic) in 2009 and the Aid flow (current US$) of Montenegro in 2013?
Ensure brevity in your answer.  1.24e+06. What is the difference between the Aid flow (current US$) in Congo (Democratic) in 2009 and the Aid flow (current US$) in Serbia in 2013?
Your answer should be compact. -9.16e+06. What is the difference between the Aid flow (current US$) in Montenegro in 2009 and the Aid flow (current US$) in Serbia in 2013?
Your response must be concise. -8.22e+06. What is the difference between the Aid flow (current US$) in Bosnia and Herzegovina in 2010 and the Aid flow (current US$) in Congo (Democratic) in 2011?
Offer a terse response. 3.07e+07. What is the difference between the Aid flow (current US$) in Bosnia and Herzegovina in 2010 and the Aid flow (current US$) in Montenegro in 2011?
Keep it short and to the point. 3.02e+07. What is the difference between the Aid flow (current US$) in Bosnia and Herzegovina in 2010 and the Aid flow (current US$) in Serbia in 2011?
Offer a terse response. 2.10e+07. What is the difference between the Aid flow (current US$) in Congo (Democratic) in 2010 and the Aid flow (current US$) in Montenegro in 2011?
Offer a terse response. 1.28e+08. What is the difference between the Aid flow (current US$) of Congo (Democratic) in 2010 and the Aid flow (current US$) of Serbia in 2011?
Your answer should be compact. 1.19e+08. What is the difference between the Aid flow (current US$) in Montenegro in 2010 and the Aid flow (current US$) in Serbia in 2011?
Provide a short and direct response. -8.22e+06. What is the difference between the Aid flow (current US$) in Bosnia and Herzegovina in 2010 and the Aid flow (current US$) in Congo (Democratic) in 2012?
Offer a terse response. 3.11e+07. What is the difference between the Aid flow (current US$) in Bosnia and Herzegovina in 2010 and the Aid flow (current US$) in Montenegro in 2012?
Offer a terse response. 3.04e+07. What is the difference between the Aid flow (current US$) in Bosnia and Herzegovina in 2010 and the Aid flow (current US$) in Serbia in 2012?
Your answer should be compact. 2.01e+07. What is the difference between the Aid flow (current US$) in Congo (Democratic) in 2010 and the Aid flow (current US$) in Montenegro in 2012?
Provide a short and direct response. 1.29e+08. What is the difference between the Aid flow (current US$) in Congo (Democratic) in 2010 and the Aid flow (current US$) in Serbia in 2012?
Provide a short and direct response. 1.18e+08. What is the difference between the Aid flow (current US$) in Montenegro in 2010 and the Aid flow (current US$) in Serbia in 2012?
Ensure brevity in your answer.  -9.16e+06. What is the difference between the Aid flow (current US$) in Bosnia and Herzegovina in 2010 and the Aid flow (current US$) in Congo (Democratic) in 2013?
Provide a short and direct response. 3.10e+07. What is the difference between the Aid flow (current US$) of Bosnia and Herzegovina in 2010 and the Aid flow (current US$) of Montenegro in 2013?
Your answer should be very brief. 3.02e+07. What is the difference between the Aid flow (current US$) in Bosnia and Herzegovina in 2010 and the Aid flow (current US$) in Serbia in 2013?
Your answer should be compact. 1.98e+07. What is the difference between the Aid flow (current US$) in Congo (Democratic) in 2010 and the Aid flow (current US$) in Montenegro in 2013?
Offer a terse response. 1.28e+08. What is the difference between the Aid flow (current US$) in Congo (Democratic) in 2010 and the Aid flow (current US$) in Serbia in 2013?
Ensure brevity in your answer.  1.18e+08. What is the difference between the Aid flow (current US$) of Montenegro in 2010 and the Aid flow (current US$) of Serbia in 2013?
Offer a terse response. -9.44e+06. What is the difference between the Aid flow (current US$) of Bosnia and Herzegovina in 2011 and the Aid flow (current US$) of Congo (Democratic) in 2012?
Ensure brevity in your answer.  2.68e+07. What is the difference between the Aid flow (current US$) of Bosnia and Herzegovina in 2011 and the Aid flow (current US$) of Montenegro in 2012?
Offer a terse response. 2.60e+07. What is the difference between the Aid flow (current US$) of Bosnia and Herzegovina in 2011 and the Aid flow (current US$) of Serbia in 2012?
Ensure brevity in your answer.  1.57e+07. What is the difference between the Aid flow (current US$) of Congo (Democratic) in 2011 and the Aid flow (current US$) of Montenegro in 2012?
Your response must be concise. -2.50e+05. What is the difference between the Aid flow (current US$) of Congo (Democratic) in 2011 and the Aid flow (current US$) of Serbia in 2012?
Provide a short and direct response. -1.06e+07. What is the difference between the Aid flow (current US$) of Montenegro in 2011 and the Aid flow (current US$) of Serbia in 2012?
Keep it short and to the point. -1.02e+07. What is the difference between the Aid flow (current US$) in Bosnia and Herzegovina in 2011 and the Aid flow (current US$) in Congo (Democratic) in 2013?
Your response must be concise. 2.66e+07. What is the difference between the Aid flow (current US$) in Bosnia and Herzegovina in 2011 and the Aid flow (current US$) in Montenegro in 2013?
Make the answer very short. 2.58e+07. What is the difference between the Aid flow (current US$) of Bosnia and Herzegovina in 2011 and the Aid flow (current US$) of Serbia in 2013?
Provide a short and direct response. 1.54e+07. What is the difference between the Aid flow (current US$) in Congo (Democratic) in 2011 and the Aid flow (current US$) in Montenegro in 2013?
Provide a short and direct response. -4.80e+05. What is the difference between the Aid flow (current US$) of Congo (Democratic) in 2011 and the Aid flow (current US$) of Serbia in 2013?
Ensure brevity in your answer.  -1.09e+07. What is the difference between the Aid flow (current US$) in Montenegro in 2011 and the Aid flow (current US$) in Serbia in 2013?
Ensure brevity in your answer.  -1.04e+07. What is the difference between the Aid flow (current US$) of Bosnia and Herzegovina in 2012 and the Aid flow (current US$) of Congo (Democratic) in 2013?
Provide a short and direct response. 2.74e+07. What is the difference between the Aid flow (current US$) in Bosnia and Herzegovina in 2012 and the Aid flow (current US$) in Montenegro in 2013?
Provide a short and direct response. 2.66e+07. What is the difference between the Aid flow (current US$) in Bosnia and Herzegovina in 2012 and the Aid flow (current US$) in Serbia in 2013?
Provide a short and direct response. 1.62e+07. What is the difference between the Aid flow (current US$) of Congo (Democratic) in 2012 and the Aid flow (current US$) of Montenegro in 2013?
Make the answer very short. -9.50e+05. What is the difference between the Aid flow (current US$) of Congo (Democratic) in 2012 and the Aid flow (current US$) of Serbia in 2013?
Provide a short and direct response. -1.14e+07. What is the difference between the Aid flow (current US$) in Montenegro in 2012 and the Aid flow (current US$) in Serbia in 2013?
Offer a terse response. -1.06e+07. What is the average Aid flow (current US$) in Bosnia and Herzegovina per year?
Offer a very short reply. 2.97e+07. What is the average Aid flow (current US$) of Congo (Democratic) per year?
Offer a terse response. 1.88e+07. What is the average Aid flow (current US$) in Montenegro per year?
Your answer should be compact. 2.34e+06. What is the average Aid flow (current US$) of Serbia per year?
Give a very brief answer. 2.24e+07. In the year 2006, what is the difference between the Aid flow (current US$) in Bosnia and Herzegovina and Aid flow (current US$) in Congo (Democratic)?
Your answer should be very brief. 2.47e+07. In the year 2006, what is the difference between the Aid flow (current US$) in Bosnia and Herzegovina and Aid flow (current US$) in Montenegro?
Keep it short and to the point. 2.57e+07. In the year 2006, what is the difference between the Aid flow (current US$) in Bosnia and Herzegovina and Aid flow (current US$) in Serbia?
Offer a very short reply. -2.62e+07. In the year 2006, what is the difference between the Aid flow (current US$) of Congo (Democratic) and Aid flow (current US$) of Montenegro?
Make the answer very short. 1.07e+06. In the year 2006, what is the difference between the Aid flow (current US$) in Congo (Democratic) and Aid flow (current US$) in Serbia?
Ensure brevity in your answer.  -5.08e+07. In the year 2006, what is the difference between the Aid flow (current US$) of Montenegro and Aid flow (current US$) of Serbia?
Give a very brief answer. -5.19e+07. In the year 2007, what is the difference between the Aid flow (current US$) in Bosnia and Herzegovina and Aid flow (current US$) in Congo (Democratic)?
Ensure brevity in your answer.  2.71e+07. In the year 2007, what is the difference between the Aid flow (current US$) in Bosnia and Herzegovina and Aid flow (current US$) in Montenegro?
Ensure brevity in your answer.  3.01e+07. In the year 2007, what is the difference between the Aid flow (current US$) in Bosnia and Herzegovina and Aid flow (current US$) in Serbia?
Give a very brief answer. 1.75e+06. In the year 2007, what is the difference between the Aid flow (current US$) of Congo (Democratic) and Aid flow (current US$) of Montenegro?
Make the answer very short. 2.98e+06. In the year 2007, what is the difference between the Aid flow (current US$) of Congo (Democratic) and Aid flow (current US$) of Serbia?
Provide a short and direct response. -2.54e+07. In the year 2007, what is the difference between the Aid flow (current US$) of Montenegro and Aid flow (current US$) of Serbia?
Offer a terse response. -2.84e+07. In the year 2008, what is the difference between the Aid flow (current US$) of Bosnia and Herzegovina and Aid flow (current US$) of Congo (Democratic)?
Give a very brief answer. 3.16e+07. In the year 2008, what is the difference between the Aid flow (current US$) in Bosnia and Herzegovina and Aid flow (current US$) in Montenegro?
Provide a succinct answer. 3.44e+07. In the year 2008, what is the difference between the Aid flow (current US$) of Bosnia and Herzegovina and Aid flow (current US$) of Serbia?
Offer a terse response. 4.31e+06. In the year 2008, what is the difference between the Aid flow (current US$) of Congo (Democratic) and Aid flow (current US$) of Montenegro?
Your answer should be very brief. 2.80e+06. In the year 2008, what is the difference between the Aid flow (current US$) of Congo (Democratic) and Aid flow (current US$) of Serbia?
Ensure brevity in your answer.  -2.73e+07. In the year 2008, what is the difference between the Aid flow (current US$) of Montenegro and Aid flow (current US$) of Serbia?
Your answer should be compact. -3.01e+07. In the year 2009, what is the difference between the Aid flow (current US$) of Bosnia and Herzegovina and Aid flow (current US$) of Congo (Democratic)?
Offer a very short reply. 2.62e+07. In the year 2009, what is the difference between the Aid flow (current US$) of Bosnia and Herzegovina and Aid flow (current US$) of Montenegro?
Give a very brief answer. 2.52e+07. In the year 2009, what is the difference between the Aid flow (current US$) in Bosnia and Herzegovina and Aid flow (current US$) in Serbia?
Offer a very short reply. 1.62e+07. In the year 2009, what is the difference between the Aid flow (current US$) in Congo (Democratic) and Aid flow (current US$) in Montenegro?
Make the answer very short. -9.40e+05. In the year 2009, what is the difference between the Aid flow (current US$) in Congo (Democratic) and Aid flow (current US$) in Serbia?
Your answer should be compact. -9.97e+06. In the year 2009, what is the difference between the Aid flow (current US$) of Montenegro and Aid flow (current US$) of Serbia?
Provide a short and direct response. -9.03e+06. In the year 2010, what is the difference between the Aid flow (current US$) of Bosnia and Herzegovina and Aid flow (current US$) of Congo (Democratic)?
Offer a terse response. -9.83e+07. In the year 2010, what is the difference between the Aid flow (current US$) of Bosnia and Herzegovina and Aid flow (current US$) of Montenegro?
Ensure brevity in your answer.  2.92e+07. In the year 2010, what is the difference between the Aid flow (current US$) of Bosnia and Herzegovina and Aid flow (current US$) of Serbia?
Give a very brief answer. 1.82e+07. In the year 2010, what is the difference between the Aid flow (current US$) of Congo (Democratic) and Aid flow (current US$) of Montenegro?
Make the answer very short. 1.27e+08. In the year 2010, what is the difference between the Aid flow (current US$) of Congo (Democratic) and Aid flow (current US$) of Serbia?
Ensure brevity in your answer.  1.16e+08. In the year 2010, what is the difference between the Aid flow (current US$) in Montenegro and Aid flow (current US$) in Serbia?
Give a very brief answer. -1.10e+07. In the year 2011, what is the difference between the Aid flow (current US$) of Bosnia and Herzegovina and Aid flow (current US$) of Congo (Democratic)?
Ensure brevity in your answer.  2.63e+07. In the year 2011, what is the difference between the Aid flow (current US$) in Bosnia and Herzegovina and Aid flow (current US$) in Montenegro?
Ensure brevity in your answer.  2.58e+07. In the year 2011, what is the difference between the Aid flow (current US$) in Bosnia and Herzegovina and Aid flow (current US$) in Serbia?
Keep it short and to the point. 1.66e+07. In the year 2011, what is the difference between the Aid flow (current US$) in Congo (Democratic) and Aid flow (current US$) in Montenegro?
Keep it short and to the point. -4.50e+05. In the year 2011, what is the difference between the Aid flow (current US$) in Congo (Democratic) and Aid flow (current US$) in Serbia?
Ensure brevity in your answer.  -9.66e+06. In the year 2011, what is the difference between the Aid flow (current US$) in Montenegro and Aid flow (current US$) in Serbia?
Your response must be concise. -9.21e+06. In the year 2012, what is the difference between the Aid flow (current US$) in Bosnia and Herzegovina and Aid flow (current US$) in Congo (Democratic)?
Your answer should be very brief. 2.75e+07. In the year 2012, what is the difference between the Aid flow (current US$) in Bosnia and Herzegovina and Aid flow (current US$) in Montenegro?
Keep it short and to the point. 2.68e+07. In the year 2012, what is the difference between the Aid flow (current US$) of Bosnia and Herzegovina and Aid flow (current US$) of Serbia?
Provide a succinct answer. 1.65e+07. In the year 2012, what is the difference between the Aid flow (current US$) in Congo (Democratic) and Aid flow (current US$) in Montenegro?
Ensure brevity in your answer.  -7.20e+05. In the year 2012, what is the difference between the Aid flow (current US$) in Congo (Democratic) and Aid flow (current US$) in Serbia?
Offer a very short reply. -1.11e+07. In the year 2012, what is the difference between the Aid flow (current US$) in Montenegro and Aid flow (current US$) in Serbia?
Make the answer very short. -1.04e+07. In the year 2013, what is the difference between the Aid flow (current US$) in Bosnia and Herzegovina and Aid flow (current US$) in Congo (Democratic)?
Your answer should be compact. 2.23e+07. In the year 2013, what is the difference between the Aid flow (current US$) of Bosnia and Herzegovina and Aid flow (current US$) of Montenegro?
Your response must be concise. 2.15e+07. In the year 2013, what is the difference between the Aid flow (current US$) of Bosnia and Herzegovina and Aid flow (current US$) of Serbia?
Offer a terse response. 1.11e+07. In the year 2013, what is the difference between the Aid flow (current US$) of Congo (Democratic) and Aid flow (current US$) of Montenegro?
Your answer should be very brief. -8.00e+05. In the year 2013, what is the difference between the Aid flow (current US$) in Congo (Democratic) and Aid flow (current US$) in Serbia?
Offer a terse response. -1.12e+07. In the year 2013, what is the difference between the Aid flow (current US$) in Montenegro and Aid flow (current US$) in Serbia?
Provide a succinct answer. -1.04e+07. What is the ratio of the Aid flow (current US$) in Bosnia and Herzegovina in 2006 to that in 2007?
Provide a short and direct response. 0.88. What is the ratio of the Aid flow (current US$) in Congo (Democratic) in 2006 to that in 2007?
Your answer should be compact. 0.74. What is the ratio of the Aid flow (current US$) of Montenegro in 2006 to that in 2007?
Your response must be concise. 1.12. What is the ratio of the Aid flow (current US$) in Serbia in 2006 to that in 2007?
Offer a very short reply. 1.76. What is the ratio of the Aid flow (current US$) in Bosnia and Herzegovina in 2006 to that in 2008?
Provide a short and direct response. 0.77. What is the ratio of the Aid flow (current US$) of Congo (Democratic) in 2006 to that in 2008?
Offer a terse response. 0.69. What is the ratio of the Aid flow (current US$) in Montenegro in 2006 to that in 2008?
Your response must be concise. 0.93. What is the ratio of the Aid flow (current US$) in Serbia in 2006 to that in 2008?
Your response must be concise. 1.64. What is the ratio of the Aid flow (current US$) in Bosnia and Herzegovina in 2006 to that in 2009?
Make the answer very short. 1.02. What is the ratio of the Aid flow (current US$) of Congo (Democratic) in 2006 to that in 2009?
Provide a short and direct response. 1.81. What is the ratio of the Aid flow (current US$) in Serbia in 2006 to that in 2009?
Make the answer very short. 4.46. What is the ratio of the Aid flow (current US$) in Bosnia and Herzegovina in 2006 to that in 2010?
Provide a succinct answer. 0.93. What is the ratio of the Aid flow (current US$) of Congo (Democratic) in 2006 to that in 2010?
Offer a very short reply. 0.03. What is the ratio of the Aid flow (current US$) of Montenegro in 2006 to that in 2010?
Ensure brevity in your answer.  1.55. What is the ratio of the Aid flow (current US$) of Serbia in 2006 to that in 2010?
Offer a very short reply. 4.19. What is the ratio of the Aid flow (current US$) in Bosnia and Herzegovina in 2006 to that in 2011?
Keep it short and to the point. 1.08. What is the ratio of the Aid flow (current US$) of Congo (Democratic) in 2006 to that in 2011?
Ensure brevity in your answer.  6.21. What is the ratio of the Aid flow (current US$) of Montenegro in 2006 to that in 2011?
Your answer should be compact. 2.88. What is the ratio of the Aid flow (current US$) of Serbia in 2006 to that in 2011?
Give a very brief answer. 5.33. What is the ratio of the Aid flow (current US$) in Bosnia and Herzegovina in 2006 to that in 2012?
Provide a succinct answer. 1.05. What is the ratio of the Aid flow (current US$) in Congo (Democratic) in 2006 to that in 2012?
Keep it short and to the point. 18.38. What is the ratio of the Aid flow (current US$) in Montenegro in 2006 to that in 2012?
Your answer should be compact. 3.48. What is the ratio of the Aid flow (current US$) of Serbia in 2006 to that in 2012?
Provide a succinct answer. 4.89. What is the ratio of the Aid flow (current US$) in Bosnia and Herzegovina in 2006 to that in 2013?
Offer a very short reply. 1.28. What is the ratio of the Aid flow (current US$) in Congo (Democratic) in 2006 to that in 2013?
Ensure brevity in your answer.  11.31. What is the ratio of the Aid flow (current US$) in Montenegro in 2006 to that in 2013?
Keep it short and to the point. 2.81. What is the ratio of the Aid flow (current US$) of Serbia in 2006 to that in 2013?
Your answer should be compact. 4.77. What is the ratio of the Aid flow (current US$) in Bosnia and Herzegovina in 2007 to that in 2008?
Your answer should be very brief. 0.87. What is the ratio of the Aid flow (current US$) in Congo (Democratic) in 2007 to that in 2008?
Ensure brevity in your answer.  0.93. What is the ratio of the Aid flow (current US$) in Montenegro in 2007 to that in 2008?
Offer a very short reply. 0.83. What is the ratio of the Aid flow (current US$) in Serbia in 2007 to that in 2008?
Offer a very short reply. 0.93. What is the ratio of the Aid flow (current US$) in Bosnia and Herzegovina in 2007 to that in 2009?
Provide a short and direct response. 1.16. What is the ratio of the Aid flow (current US$) of Congo (Democratic) in 2007 to that in 2009?
Provide a short and direct response. 2.45. What is the ratio of the Aid flow (current US$) of Montenegro in 2007 to that in 2009?
Offer a very short reply. 0.88. What is the ratio of the Aid flow (current US$) in Serbia in 2007 to that in 2009?
Provide a succinct answer. 2.53. What is the ratio of the Aid flow (current US$) in Bosnia and Herzegovina in 2007 to that in 2010?
Your answer should be very brief. 1.05. What is the ratio of the Aid flow (current US$) of Congo (Democratic) in 2007 to that in 2010?
Offer a terse response. 0.05. What is the ratio of the Aid flow (current US$) of Montenegro in 2007 to that in 2010?
Offer a very short reply. 1.38. What is the ratio of the Aid flow (current US$) of Serbia in 2007 to that in 2010?
Your answer should be very brief. 2.38. What is the ratio of the Aid flow (current US$) in Bosnia and Herzegovina in 2007 to that in 2011?
Give a very brief answer. 1.22. What is the ratio of the Aid flow (current US$) of Congo (Democratic) in 2007 to that in 2011?
Offer a terse response. 8.38. What is the ratio of the Aid flow (current US$) of Montenegro in 2007 to that in 2011?
Your answer should be very brief. 2.56. What is the ratio of the Aid flow (current US$) in Serbia in 2007 to that in 2011?
Provide a short and direct response. 3.02. What is the ratio of the Aid flow (current US$) in Bosnia and Herzegovina in 2007 to that in 2012?
Provide a succinct answer. 1.19. What is the ratio of the Aid flow (current US$) of Congo (Democratic) in 2007 to that in 2012?
Provide a succinct answer. 24.79. What is the ratio of the Aid flow (current US$) in Montenegro in 2007 to that in 2012?
Make the answer very short. 3.09. What is the ratio of the Aid flow (current US$) of Serbia in 2007 to that in 2012?
Keep it short and to the point. 2.77. What is the ratio of the Aid flow (current US$) of Bosnia and Herzegovina in 2007 to that in 2013?
Provide a short and direct response. 1.46. What is the ratio of the Aid flow (current US$) of Congo (Democratic) in 2007 to that in 2013?
Your answer should be compact. 15.26. What is the ratio of the Aid flow (current US$) of Montenegro in 2007 to that in 2013?
Offer a very short reply. 2.5. What is the ratio of the Aid flow (current US$) of Serbia in 2007 to that in 2013?
Give a very brief answer. 2.7. What is the ratio of the Aid flow (current US$) in Bosnia and Herzegovina in 2008 to that in 2009?
Your answer should be compact. 1.33. What is the ratio of the Aid flow (current US$) in Congo (Democratic) in 2008 to that in 2009?
Offer a very short reply. 2.63. What is the ratio of the Aid flow (current US$) in Montenegro in 2008 to that in 2009?
Your answer should be compact. 1.06. What is the ratio of the Aid flow (current US$) in Serbia in 2008 to that in 2009?
Offer a very short reply. 2.72. What is the ratio of the Aid flow (current US$) of Bosnia and Herzegovina in 2008 to that in 2010?
Provide a short and direct response. 1.21. What is the ratio of the Aid flow (current US$) in Congo (Democratic) in 2008 to that in 2010?
Your response must be concise. 0.05. What is the ratio of the Aid flow (current US$) of Montenegro in 2008 to that in 2010?
Keep it short and to the point. 1.67. What is the ratio of the Aid flow (current US$) of Serbia in 2008 to that in 2010?
Keep it short and to the point. 2.55. What is the ratio of the Aid flow (current US$) of Bosnia and Herzegovina in 2008 to that in 2011?
Provide a short and direct response. 1.41. What is the ratio of the Aid flow (current US$) of Congo (Democratic) in 2008 to that in 2011?
Offer a terse response. 8.99. What is the ratio of the Aid flow (current US$) of Montenegro in 2008 to that in 2011?
Make the answer very short. 3.09. What is the ratio of the Aid flow (current US$) in Serbia in 2008 to that in 2011?
Your answer should be compact. 3.25. What is the ratio of the Aid flow (current US$) in Bosnia and Herzegovina in 2008 to that in 2012?
Keep it short and to the point. 1.37. What is the ratio of the Aid flow (current US$) in Congo (Democratic) in 2008 to that in 2012?
Give a very brief answer. 26.58. What is the ratio of the Aid flow (current US$) of Montenegro in 2008 to that in 2012?
Ensure brevity in your answer.  3.73. What is the ratio of the Aid flow (current US$) in Serbia in 2008 to that in 2012?
Your answer should be compact. 2.98. What is the ratio of the Aid flow (current US$) in Bosnia and Herzegovina in 2008 to that in 2013?
Offer a terse response. 1.68. What is the ratio of the Aid flow (current US$) of Congo (Democratic) in 2008 to that in 2013?
Your answer should be compact. 16.36. What is the ratio of the Aid flow (current US$) of Montenegro in 2008 to that in 2013?
Provide a short and direct response. 3.01. What is the ratio of the Aid flow (current US$) in Serbia in 2008 to that in 2013?
Provide a succinct answer. 2.91. What is the ratio of the Aid flow (current US$) in Bosnia and Herzegovina in 2009 to that in 2010?
Your response must be concise. 0.91. What is the ratio of the Aid flow (current US$) in Congo (Democratic) in 2009 to that in 2010?
Your answer should be very brief. 0.02. What is the ratio of the Aid flow (current US$) of Montenegro in 2009 to that in 2010?
Give a very brief answer. 1.57. What is the ratio of the Aid flow (current US$) in Serbia in 2009 to that in 2010?
Your response must be concise. 0.94. What is the ratio of the Aid flow (current US$) of Bosnia and Herzegovina in 2009 to that in 2011?
Your answer should be compact. 1.06. What is the ratio of the Aid flow (current US$) in Congo (Democratic) in 2009 to that in 2011?
Your response must be concise. 3.42. What is the ratio of the Aid flow (current US$) of Montenegro in 2009 to that in 2011?
Offer a terse response. 2.91. What is the ratio of the Aid flow (current US$) in Serbia in 2009 to that in 2011?
Provide a succinct answer. 1.2. What is the ratio of the Aid flow (current US$) of Bosnia and Herzegovina in 2009 to that in 2012?
Keep it short and to the point. 1.03. What is the ratio of the Aid flow (current US$) in Congo (Democratic) in 2009 to that in 2012?
Give a very brief answer. 10.12. What is the ratio of the Aid flow (current US$) in Montenegro in 2009 to that in 2012?
Keep it short and to the point. 3.51. What is the ratio of the Aid flow (current US$) in Serbia in 2009 to that in 2012?
Your answer should be compact. 1.1. What is the ratio of the Aid flow (current US$) of Bosnia and Herzegovina in 2009 to that in 2013?
Your answer should be very brief. 1.26. What is the ratio of the Aid flow (current US$) of Congo (Democratic) in 2009 to that in 2013?
Your answer should be very brief. 6.23. What is the ratio of the Aid flow (current US$) in Montenegro in 2009 to that in 2013?
Keep it short and to the point. 2.83. What is the ratio of the Aid flow (current US$) in Serbia in 2009 to that in 2013?
Provide a succinct answer. 1.07. What is the ratio of the Aid flow (current US$) in Bosnia and Herzegovina in 2010 to that in 2011?
Keep it short and to the point. 1.16. What is the ratio of the Aid flow (current US$) of Congo (Democratic) in 2010 to that in 2011?
Offer a very short reply. 182.59. What is the ratio of the Aid flow (current US$) in Montenegro in 2010 to that in 2011?
Offer a very short reply. 1.85. What is the ratio of the Aid flow (current US$) of Serbia in 2010 to that in 2011?
Provide a succinct answer. 1.27. What is the ratio of the Aid flow (current US$) of Bosnia and Herzegovina in 2010 to that in 2012?
Offer a very short reply. 1.13. What is the ratio of the Aid flow (current US$) of Congo (Democratic) in 2010 to that in 2012?
Make the answer very short. 540.17. What is the ratio of the Aid flow (current US$) of Montenegro in 2010 to that in 2012?
Offer a very short reply. 2.24. What is the ratio of the Aid flow (current US$) in Serbia in 2010 to that in 2012?
Make the answer very short. 1.17. What is the ratio of the Aid flow (current US$) of Bosnia and Herzegovina in 2010 to that in 2013?
Give a very brief answer. 1.39. What is the ratio of the Aid flow (current US$) in Congo (Democratic) in 2010 to that in 2013?
Ensure brevity in your answer.  332.41. What is the ratio of the Aid flow (current US$) of Montenegro in 2010 to that in 2013?
Offer a very short reply. 1.81. What is the ratio of the Aid flow (current US$) in Serbia in 2010 to that in 2013?
Offer a very short reply. 1.14. What is the ratio of the Aid flow (current US$) of Bosnia and Herzegovina in 2011 to that in 2012?
Provide a short and direct response. 0.97. What is the ratio of the Aid flow (current US$) of Congo (Democratic) in 2011 to that in 2012?
Provide a short and direct response. 2.96. What is the ratio of the Aid flow (current US$) of Montenegro in 2011 to that in 2012?
Provide a short and direct response. 1.21. What is the ratio of the Aid flow (current US$) in Serbia in 2011 to that in 2012?
Offer a terse response. 0.92. What is the ratio of the Aid flow (current US$) in Bosnia and Herzegovina in 2011 to that in 2013?
Give a very brief answer. 1.19. What is the ratio of the Aid flow (current US$) of Congo (Democratic) in 2011 to that in 2013?
Offer a terse response. 1.82. What is the ratio of the Aid flow (current US$) of Montenegro in 2011 to that in 2013?
Your response must be concise. 0.97. What is the ratio of the Aid flow (current US$) in Serbia in 2011 to that in 2013?
Provide a succinct answer. 0.89. What is the ratio of the Aid flow (current US$) in Bosnia and Herzegovina in 2012 to that in 2013?
Ensure brevity in your answer.  1.23. What is the ratio of the Aid flow (current US$) in Congo (Democratic) in 2012 to that in 2013?
Provide a succinct answer. 0.62. What is the ratio of the Aid flow (current US$) of Montenegro in 2012 to that in 2013?
Keep it short and to the point. 0.81. What is the ratio of the Aid flow (current US$) of Serbia in 2012 to that in 2013?
Your answer should be compact. 0.98. What is the difference between the highest and the second highest Aid flow (current US$) in Bosnia and Herzegovina?
Your answer should be very brief. 4.92e+06. What is the difference between the highest and the second highest Aid flow (current US$) in Congo (Democratic)?
Give a very brief answer. 1.23e+08. What is the difference between the highest and the second highest Aid flow (current US$) of Serbia?
Give a very brief answer. 2.16e+07. What is the difference between the highest and the lowest Aid flow (current US$) of Bosnia and Herzegovina?
Make the answer very short. 1.54e+07. What is the difference between the highest and the lowest Aid flow (current US$) of Congo (Democratic)?
Your answer should be compact. 1.29e+08. What is the difference between the highest and the lowest Aid flow (current US$) of Montenegro?
Ensure brevity in your answer.  2.62e+06. What is the difference between the highest and the lowest Aid flow (current US$) in Serbia?
Offer a very short reply. 4.49e+07. 